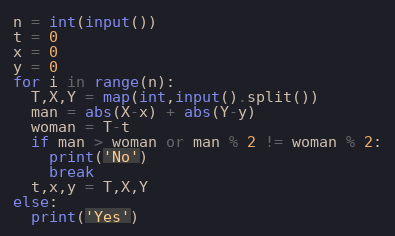Convert code to text. <code><loc_0><loc_0><loc_500><loc_500><_Python_>n = int(input())
t = 0
x = 0
y = 0
for i in range(n):
  T,X,Y = map(int,input().split())
  man = abs(X-x) + abs(Y-y)
  woman = T-t
  if man > woman or man % 2 != woman % 2:
    print('No')
    break
  t,x,y = T,X,Y
else:
  print('Yes')</code> 